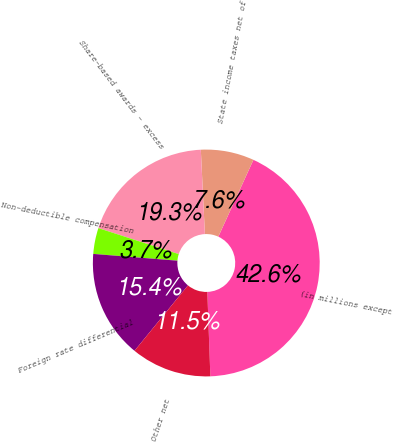Convert chart. <chart><loc_0><loc_0><loc_500><loc_500><pie_chart><fcel>(in millions except<fcel>State income taxes net of<fcel>Share-based awards - excess<fcel>Non-deductible compensation<fcel>Foreign rate differential<fcel>Other net<nl><fcel>42.61%<fcel>7.59%<fcel>19.26%<fcel>3.7%<fcel>15.37%<fcel>11.48%<nl></chart> 